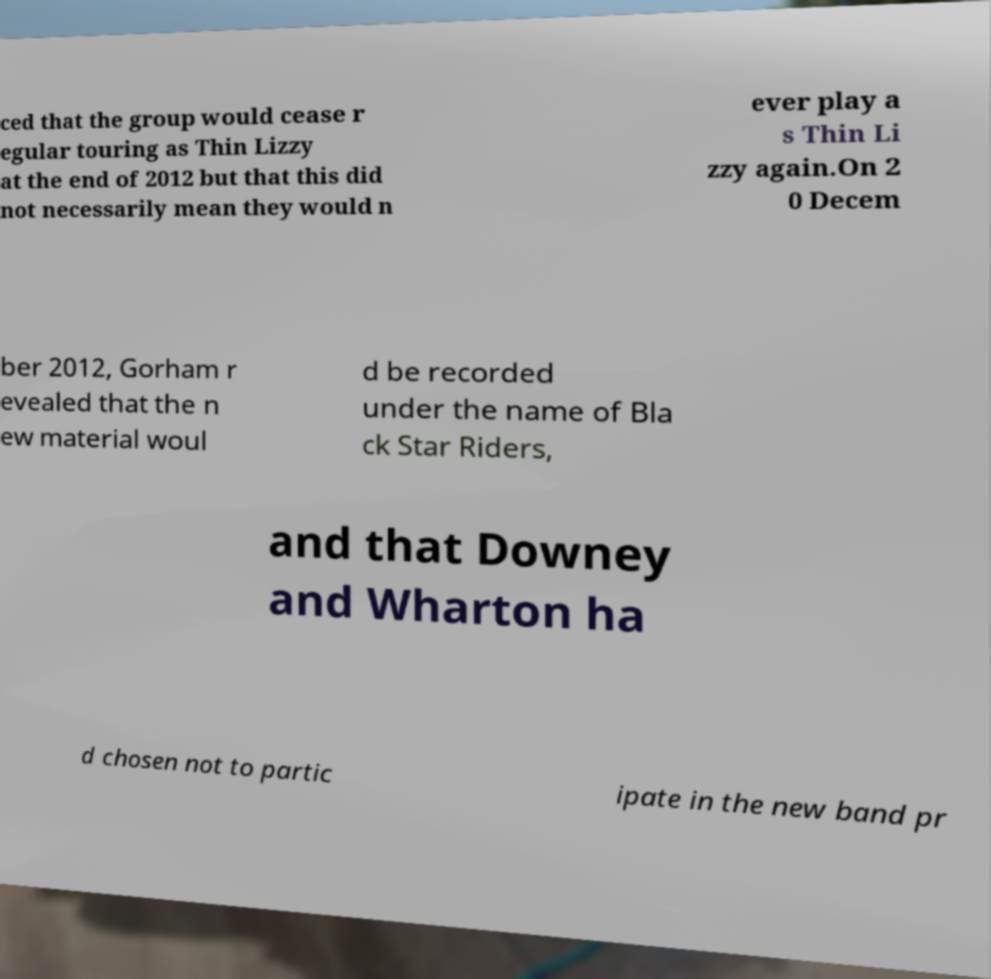Can you accurately transcribe the text from the provided image for me? ced that the group would cease r egular touring as Thin Lizzy at the end of 2012 but that this did not necessarily mean they would n ever play a s Thin Li zzy again.On 2 0 Decem ber 2012, Gorham r evealed that the n ew material woul d be recorded under the name of Bla ck Star Riders, and that Downey and Wharton ha d chosen not to partic ipate in the new band pr 